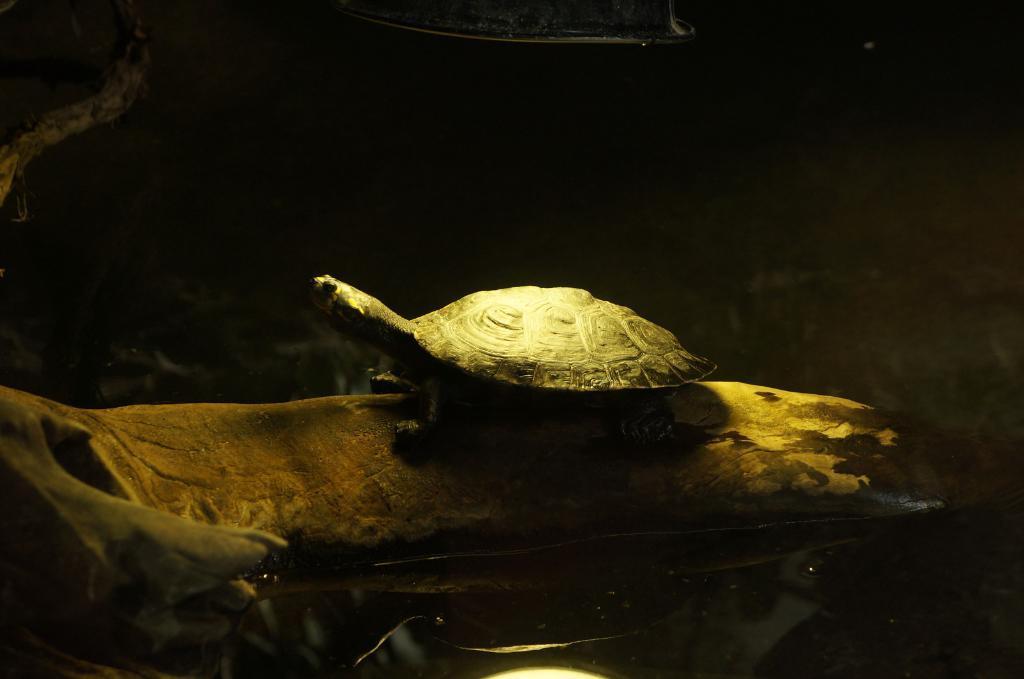In one or two sentences, can you explain what this image depicts? In this image we can see a tortoise on the surface. At the bottom of the image there is water. 